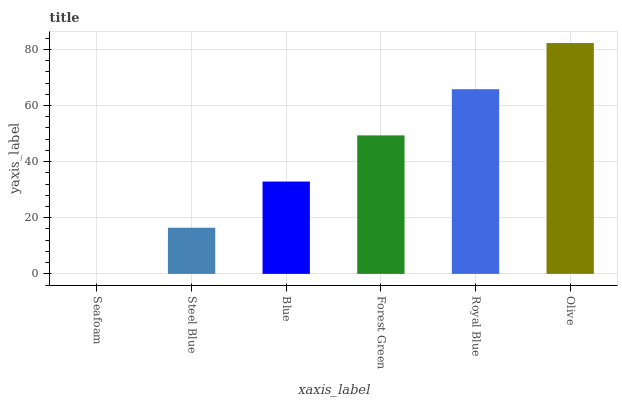Is Seafoam the minimum?
Answer yes or no. Yes. Is Olive the maximum?
Answer yes or no. Yes. Is Steel Blue the minimum?
Answer yes or no. No. Is Steel Blue the maximum?
Answer yes or no. No. Is Steel Blue greater than Seafoam?
Answer yes or no. Yes. Is Seafoam less than Steel Blue?
Answer yes or no. Yes. Is Seafoam greater than Steel Blue?
Answer yes or no. No. Is Steel Blue less than Seafoam?
Answer yes or no. No. Is Forest Green the high median?
Answer yes or no. Yes. Is Blue the low median?
Answer yes or no. Yes. Is Royal Blue the high median?
Answer yes or no. No. Is Forest Green the low median?
Answer yes or no. No. 